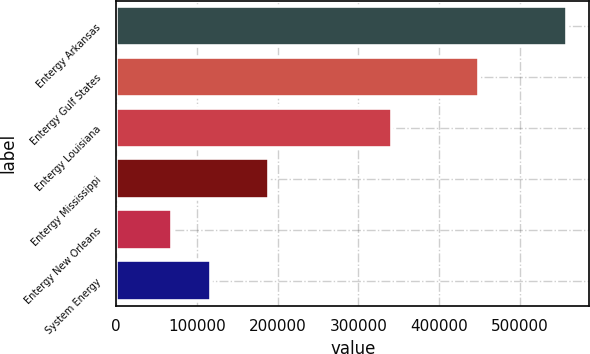<chart> <loc_0><loc_0><loc_500><loc_500><bar_chart><fcel>Entergy Arkansas<fcel>Entergy Gulf States<fcel>Entergy Louisiana<fcel>Entergy Mississippi<fcel>Entergy New Orleans<fcel>System Energy<nl><fcel>558283<fcel>449986<fcel>341681<fcel>189119<fcel>69202<fcel>118110<nl></chart> 